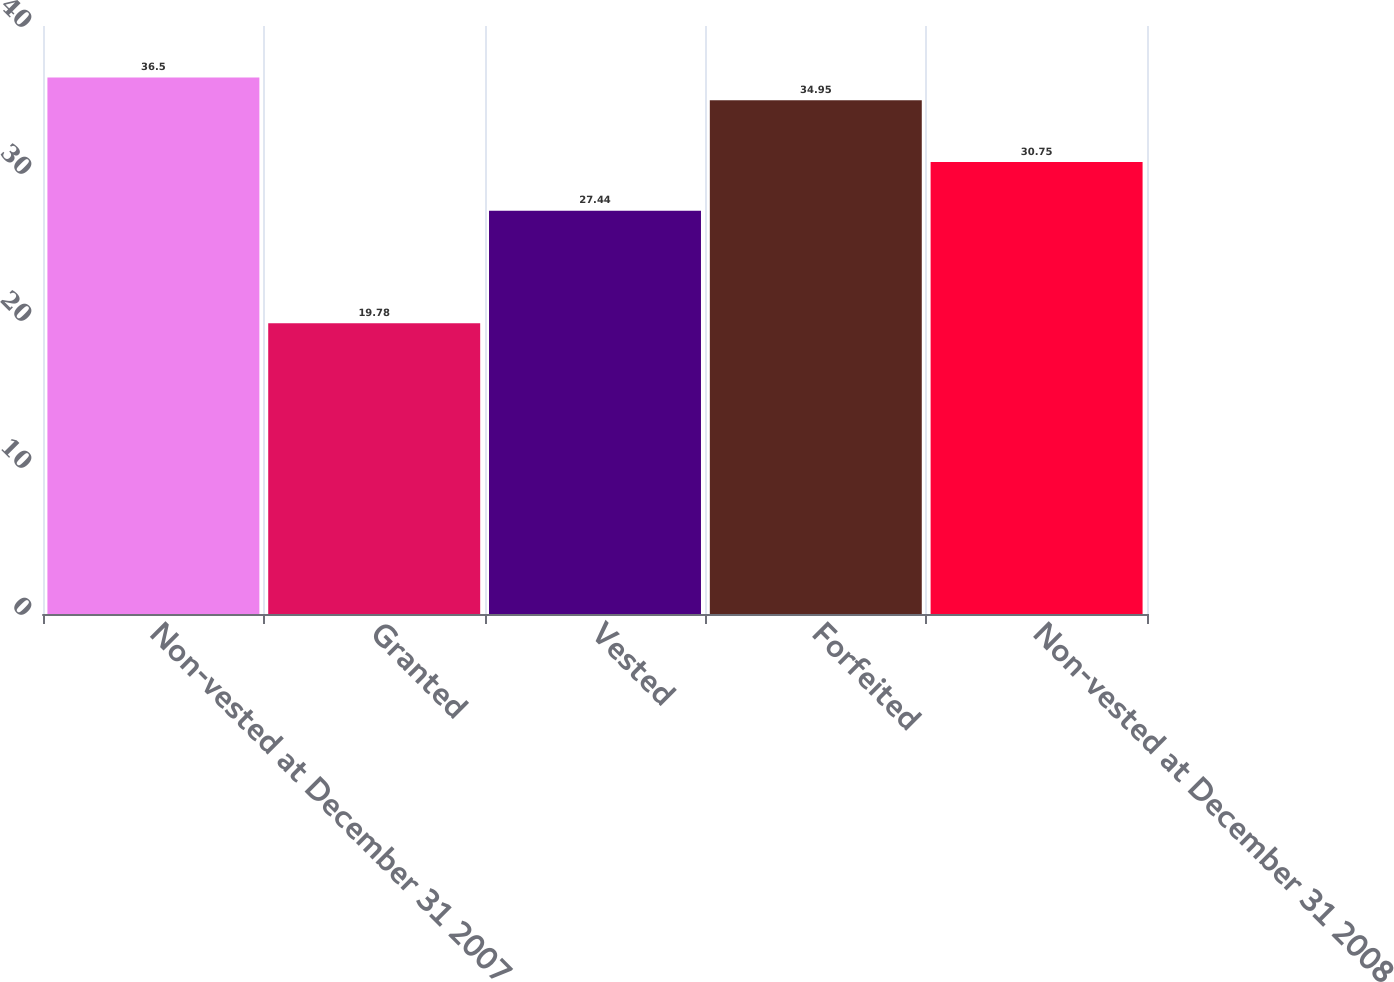Convert chart to OTSL. <chart><loc_0><loc_0><loc_500><loc_500><bar_chart><fcel>Non-vested at December 31 2007<fcel>Granted<fcel>Vested<fcel>Forfeited<fcel>Non-vested at December 31 2008<nl><fcel>36.5<fcel>19.78<fcel>27.44<fcel>34.95<fcel>30.75<nl></chart> 